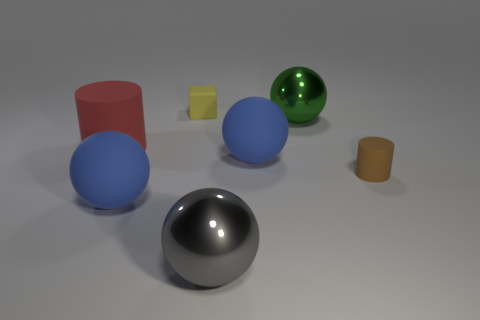What is the color of the other matte thing that is the same shape as the red matte object?
Provide a short and direct response. Brown. Is there anything else of the same color as the tiny rubber cylinder?
Offer a terse response. No. Is the size of the cylinder that is on the right side of the yellow matte object the same as the blue rubber ball that is to the left of the large gray sphere?
Offer a terse response. No. Is the number of shiny balls that are in front of the tiny brown matte cylinder the same as the number of matte cylinders that are on the left side of the yellow cube?
Make the answer very short. Yes. Do the cube and the cylinder that is in front of the large red object have the same size?
Your answer should be compact. Yes. There is a blue sphere that is to the left of the yellow rubber thing; are there any matte spheres in front of it?
Keep it short and to the point. No. Are there any other large matte things that have the same shape as the red thing?
Provide a succinct answer. No. What number of large blue spheres are on the right side of the big shiny object that is behind the small brown matte thing that is on the right side of the gray ball?
Make the answer very short. 0. Does the small cylinder have the same color as the tiny rubber thing that is left of the big green object?
Keep it short and to the point. No. How many things are tiny things that are behind the large red object or blue objects on the left side of the gray object?
Offer a terse response. 2. 